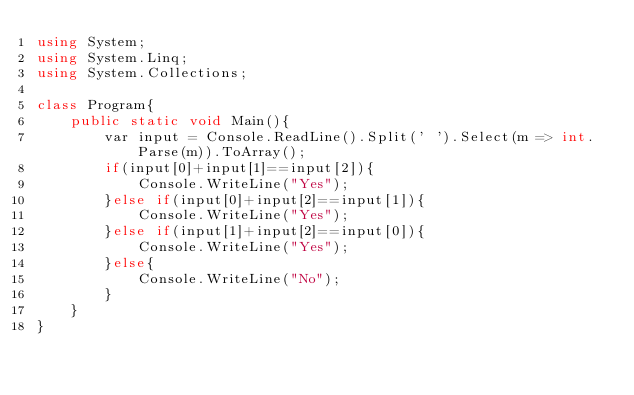Convert code to text. <code><loc_0><loc_0><loc_500><loc_500><_C#_>using System;
using System.Linq;
using System.Collections;

class Program{
    public static void Main(){
        var input = Console.ReadLine().Split(' ').Select(m => int.Parse(m)).ToArray();
        if(input[0]+input[1]==input[2]){
            Console.WriteLine("Yes");
        }else if(input[0]+input[2]==input[1]){
            Console.WriteLine("Yes");
        }else if(input[1]+input[2]==input[0]){
            Console.WriteLine("Yes");
        }else{
            Console.WriteLine("No");
        }
    }
}
</code> 